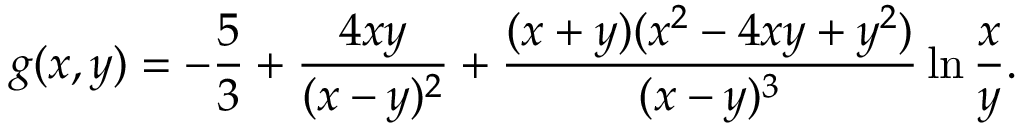Convert formula to latex. <formula><loc_0><loc_0><loc_500><loc_500>g ( x , y ) = - { \frac { 5 } { 3 } } + { \frac { 4 x y } { ( x - y ) ^ { 2 } } } + { \frac { ( x + y ) ( x ^ { 2 } - 4 x y + y ^ { 2 } ) } { ( x - y ) ^ { 3 } } } \ln { \frac { x } { y } } .</formula> 